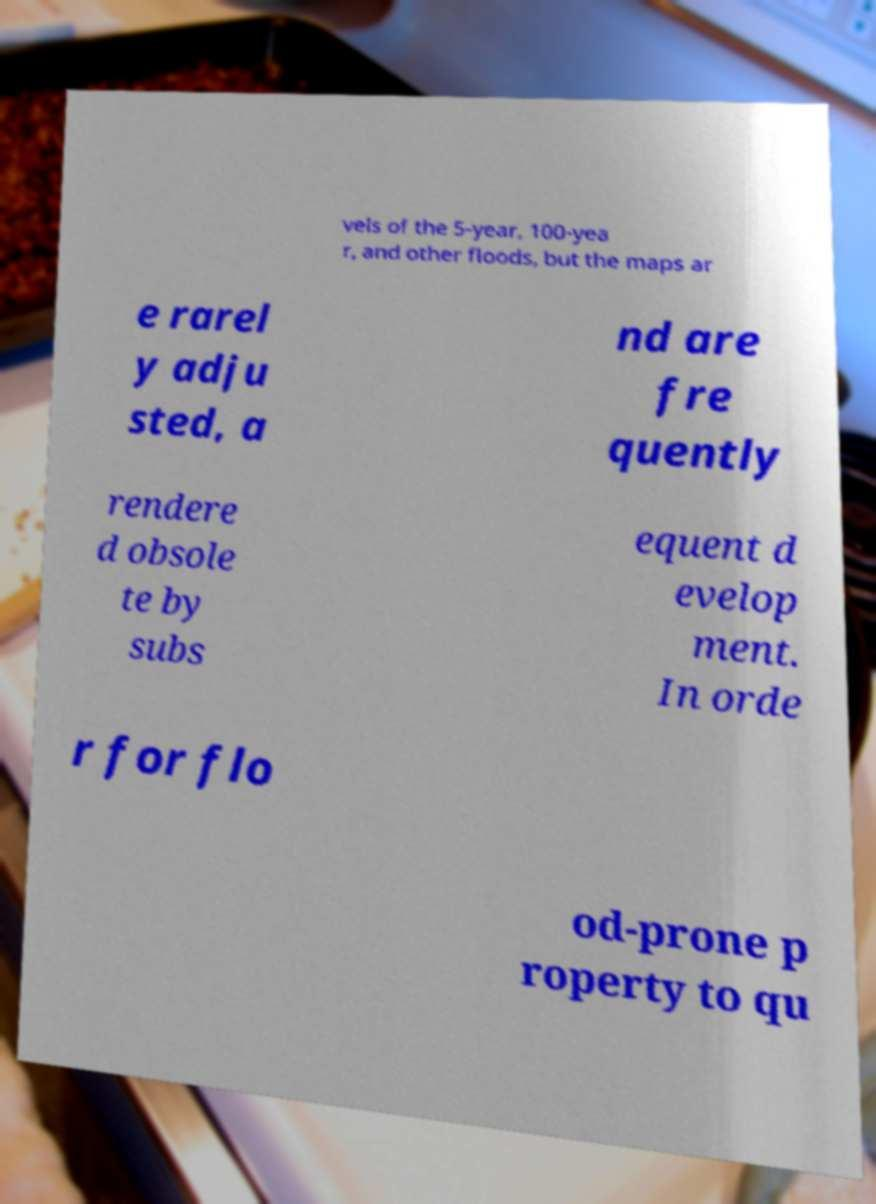There's text embedded in this image that I need extracted. Can you transcribe it verbatim? vels of the 5-year, 100-yea r, and other floods, but the maps ar e rarel y adju sted, a nd are fre quently rendere d obsole te by subs equent d evelop ment. In orde r for flo od-prone p roperty to qu 